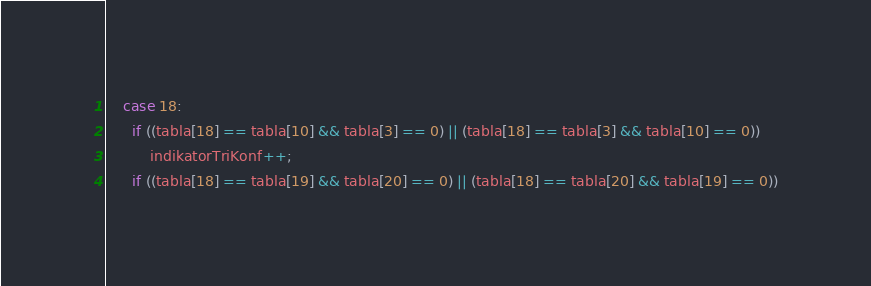Convert code to text. <code><loc_0><loc_0><loc_500><loc_500><_C++_>
    case 18:
      if ((tabla[18] == tabla[10] && tabla[3] == 0) || (tabla[18] == tabla[3] && tabla[10] == 0))
          indikatorTriKonf++;
      if ((tabla[18] == tabla[19] && tabla[20] == 0) || (tabla[18] == tabla[20] && tabla[19] == 0))</code> 